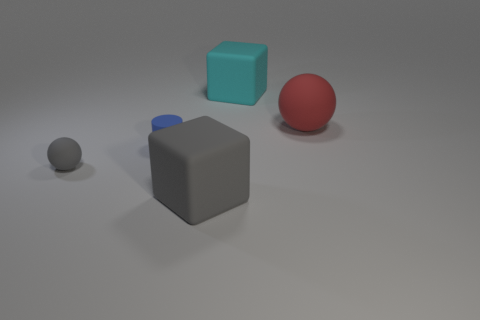Add 4 big gray blocks. How many objects exist? 9 Subtract all cylinders. How many objects are left? 4 Subtract 1 red spheres. How many objects are left? 4 Subtract all gray cubes. Subtract all cyan cylinders. How many objects are left? 4 Add 2 tiny objects. How many tiny objects are left? 4 Add 5 green matte objects. How many green matte objects exist? 5 